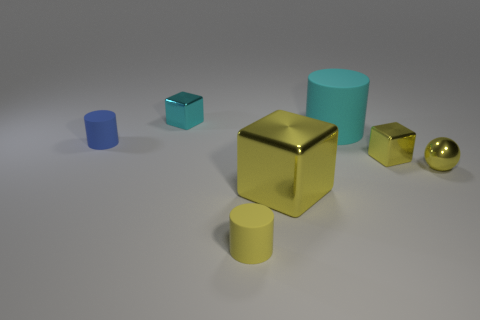What time of day or lighting conditions does the setting seem to represent? The image seems to indicate an indoor setting with artificial lighting. The shadows are soft and diffused, suggesting ambient light sources, typical of a controlled indoor environment rather than natural light which would create sharper shadows. 